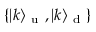<formula> <loc_0><loc_0><loc_500><loc_500>\{ | k \rangle _ { u } , | k \rangle _ { d } \}</formula> 